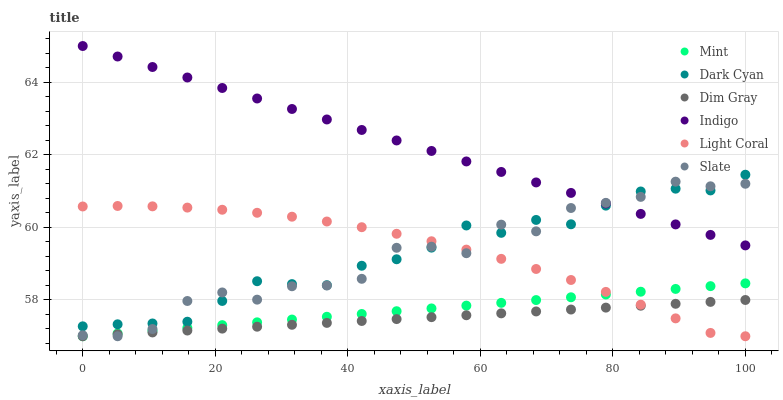Does Dim Gray have the minimum area under the curve?
Answer yes or no. Yes. Does Indigo have the maximum area under the curve?
Answer yes or no. Yes. Does Slate have the minimum area under the curve?
Answer yes or no. No. Does Slate have the maximum area under the curve?
Answer yes or no. No. Is Dim Gray the smoothest?
Answer yes or no. Yes. Is Slate the roughest?
Answer yes or no. Yes. Is Indigo the smoothest?
Answer yes or no. No. Is Indigo the roughest?
Answer yes or no. No. Does Dim Gray have the lowest value?
Answer yes or no. Yes. Does Indigo have the lowest value?
Answer yes or no. No. Does Indigo have the highest value?
Answer yes or no. Yes. Does Slate have the highest value?
Answer yes or no. No. Is Dim Gray less than Dark Cyan?
Answer yes or no. Yes. Is Indigo greater than Dim Gray?
Answer yes or no. Yes. Does Mint intersect Slate?
Answer yes or no. Yes. Is Mint less than Slate?
Answer yes or no. No. Is Mint greater than Slate?
Answer yes or no. No. Does Dim Gray intersect Dark Cyan?
Answer yes or no. No. 